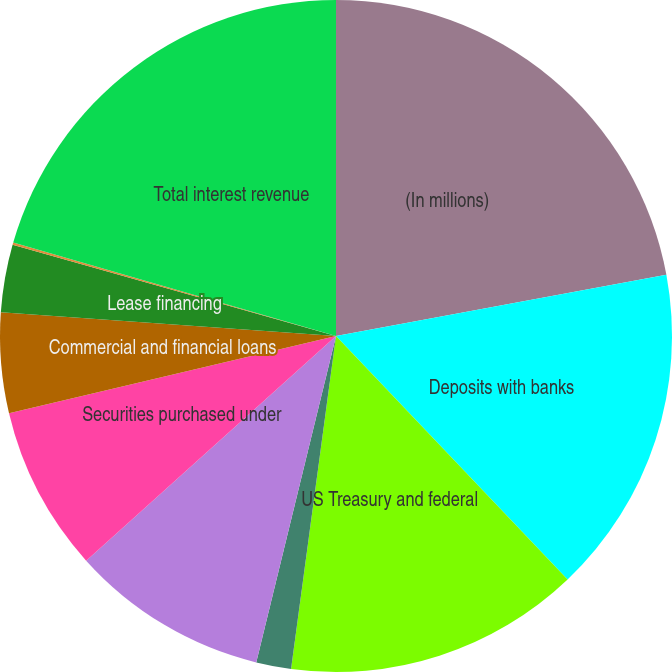<chart> <loc_0><loc_0><loc_500><loc_500><pie_chart><fcel>(In millions)<fcel>Deposits with banks<fcel>US Treasury and federal<fcel>Stateand political<fcel>Other investments<fcel>Securities purchased under<fcel>Commercial and financial loans<fcel>Lease financing<fcel>Trading account assets<fcel>Total interest revenue<nl><fcel>22.09%<fcel>15.81%<fcel>14.24%<fcel>1.68%<fcel>9.53%<fcel>7.96%<fcel>4.82%<fcel>3.25%<fcel>0.11%<fcel>20.52%<nl></chart> 